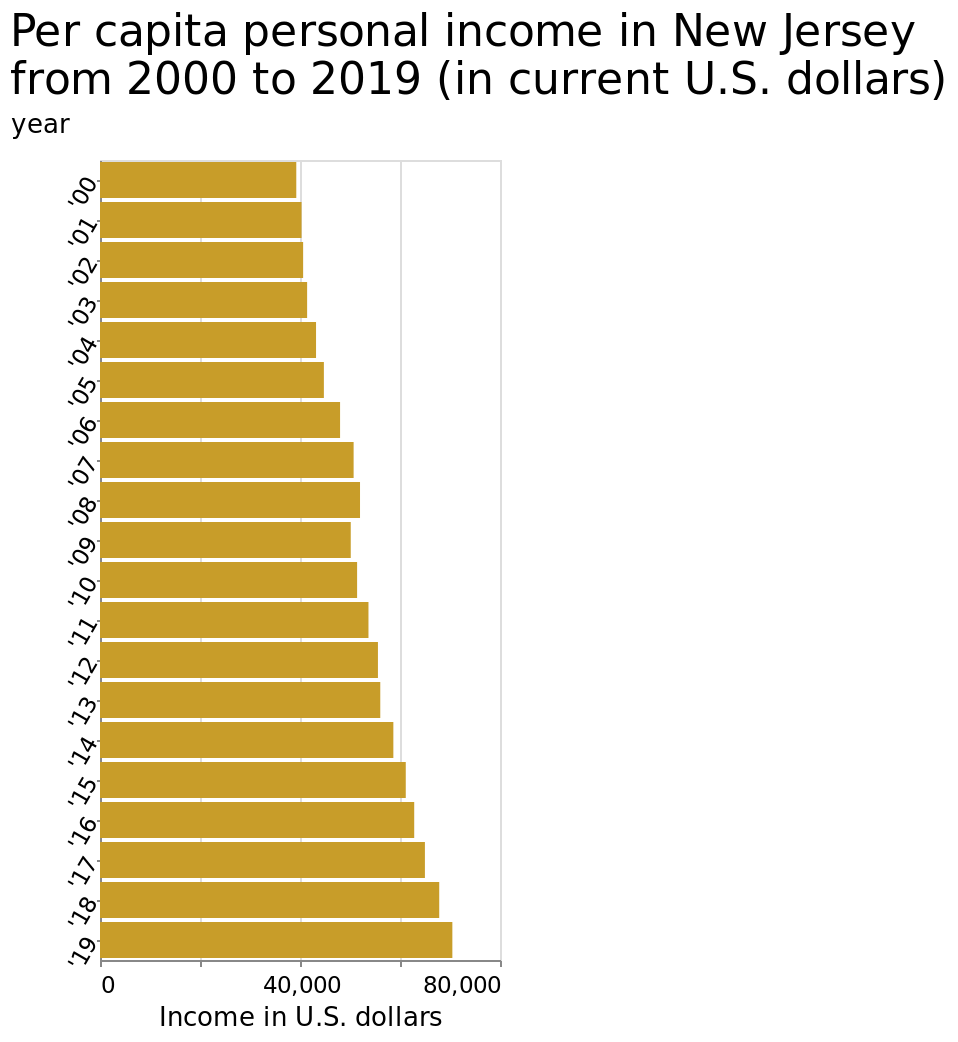<image>
Has the per capita income in New Jersey fluctuated or remained stable from 2000 to 2019?  The per capita income in New Jersey has shown a steady upward trend without major fluctuations from 2000 to 2019. please summary the statistics and relations of the chart The per capita income in New Jersey from 2000 and to 2019 has year on year ear grown steadily and people have better incomes now than 2000. 